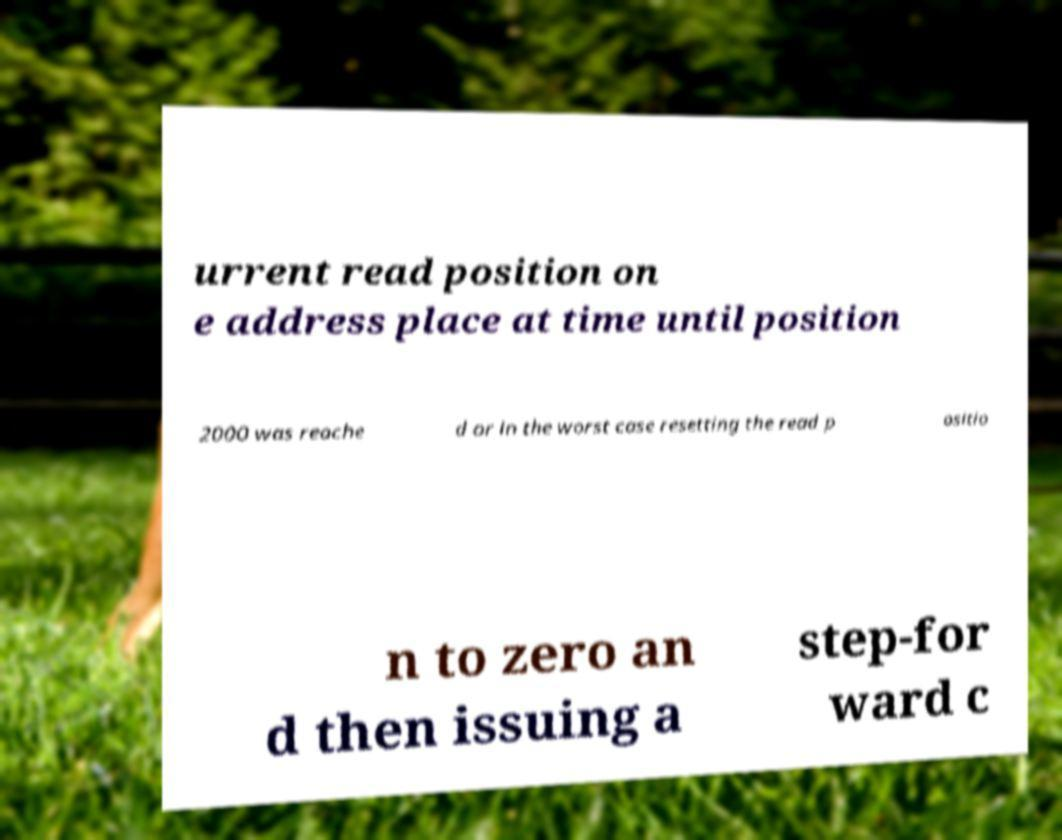Could you assist in decoding the text presented in this image and type it out clearly? urrent read position on e address place at time until position 2000 was reache d or in the worst case resetting the read p ositio n to zero an d then issuing a step-for ward c 